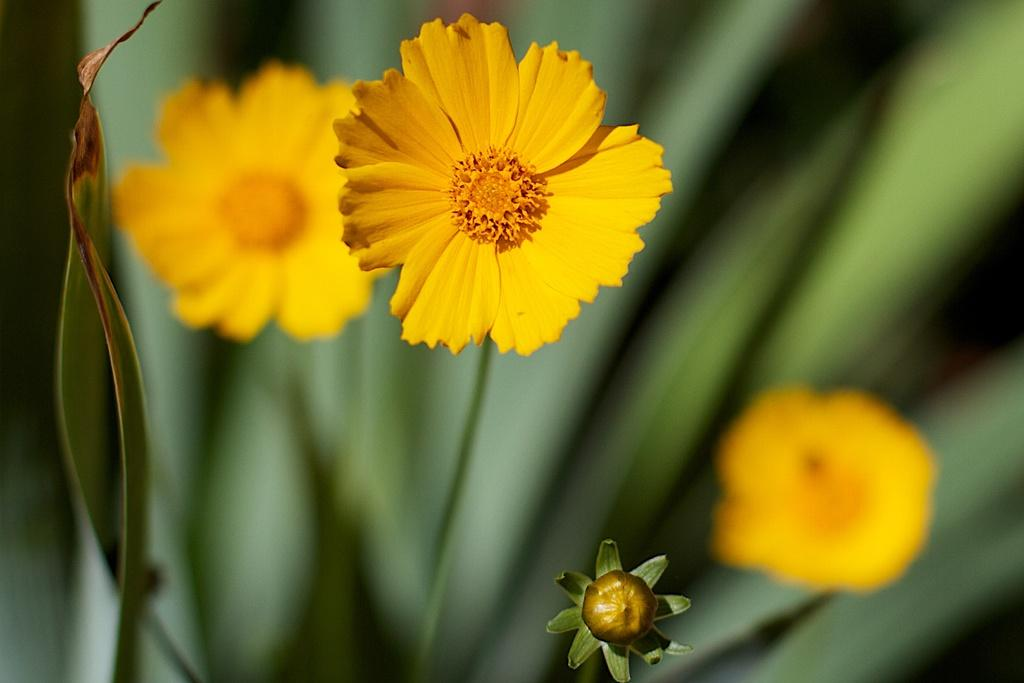What type of plants are visible in the image? There are flowers in the image. What else can be seen in the background of the image? The background of the image includes leaves. Can you describe the quality of the image? The image is blurry. Is there a trail of linen visible in the image? There is no trail of linen present in the image. Can you see a rat hiding among the flowers in the image? There is no rat present in the image; it only features flowers and leaves. 